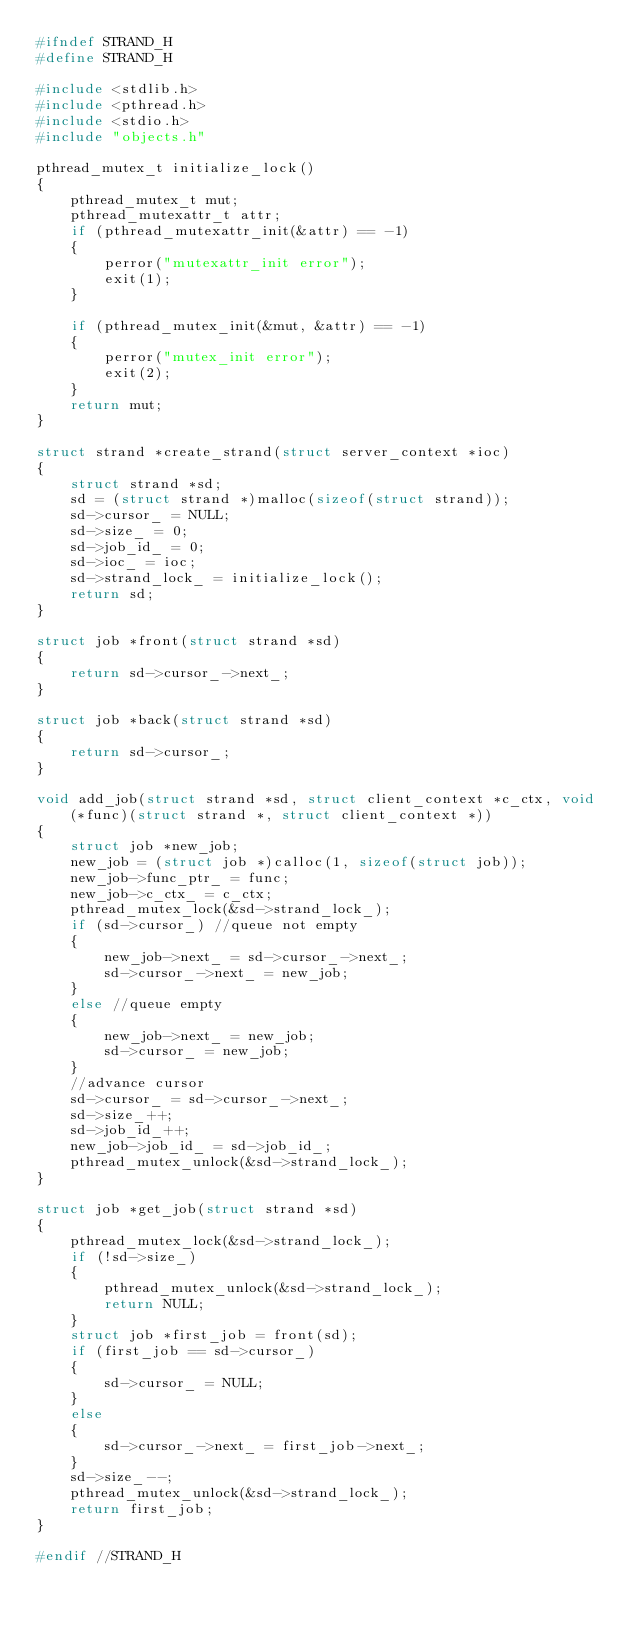<code> <loc_0><loc_0><loc_500><loc_500><_C_>#ifndef STRAND_H
#define STRAND_H

#include <stdlib.h>
#include <pthread.h>
#include <stdio.h>
#include "objects.h"

pthread_mutex_t initialize_lock()
{
    pthread_mutex_t mut;
    pthread_mutexattr_t attr;
    if (pthread_mutexattr_init(&attr) == -1)
    {
        perror("mutexattr_init error");
        exit(1);
    }

    if (pthread_mutex_init(&mut, &attr) == -1)
    {
        perror("mutex_init error");
        exit(2);
    }
    return mut;
}

struct strand *create_strand(struct server_context *ioc)
{
    struct strand *sd;
    sd = (struct strand *)malloc(sizeof(struct strand));
    sd->cursor_ = NULL;
    sd->size_ = 0;
    sd->job_id_ = 0;
    sd->ioc_ = ioc;
    sd->strand_lock_ = initialize_lock();
    return sd;
}

struct job *front(struct strand *sd)
{
    return sd->cursor_->next_;
}

struct job *back(struct strand *sd)
{
    return sd->cursor_;
}

void add_job(struct strand *sd, struct client_context *c_ctx, void (*func)(struct strand *, struct client_context *))
{
    struct job *new_job;
    new_job = (struct job *)calloc(1, sizeof(struct job));
    new_job->func_ptr_ = func;
    new_job->c_ctx_ = c_ctx;
    pthread_mutex_lock(&sd->strand_lock_);
    if (sd->cursor_) //queue not empty
    {
        new_job->next_ = sd->cursor_->next_;
        sd->cursor_->next_ = new_job;
    }
    else //queue empty
    {
        new_job->next_ = new_job;
        sd->cursor_ = new_job;
    }
    //advance cursor
    sd->cursor_ = sd->cursor_->next_;
    sd->size_++;
    sd->job_id_++;
    new_job->job_id_ = sd->job_id_;
    pthread_mutex_unlock(&sd->strand_lock_);
}

struct job *get_job(struct strand *sd)
{
    pthread_mutex_lock(&sd->strand_lock_);
    if (!sd->size_)
    {
        pthread_mutex_unlock(&sd->strand_lock_);
        return NULL;
    }
    struct job *first_job = front(sd);
    if (first_job == sd->cursor_)
    {
        sd->cursor_ = NULL;
    }
    else
    {
        sd->cursor_->next_ = first_job->next_;
    }
    sd->size_--;
    pthread_mutex_unlock(&sd->strand_lock_);
    return first_job;
}

#endif //STRAND_H</code> 